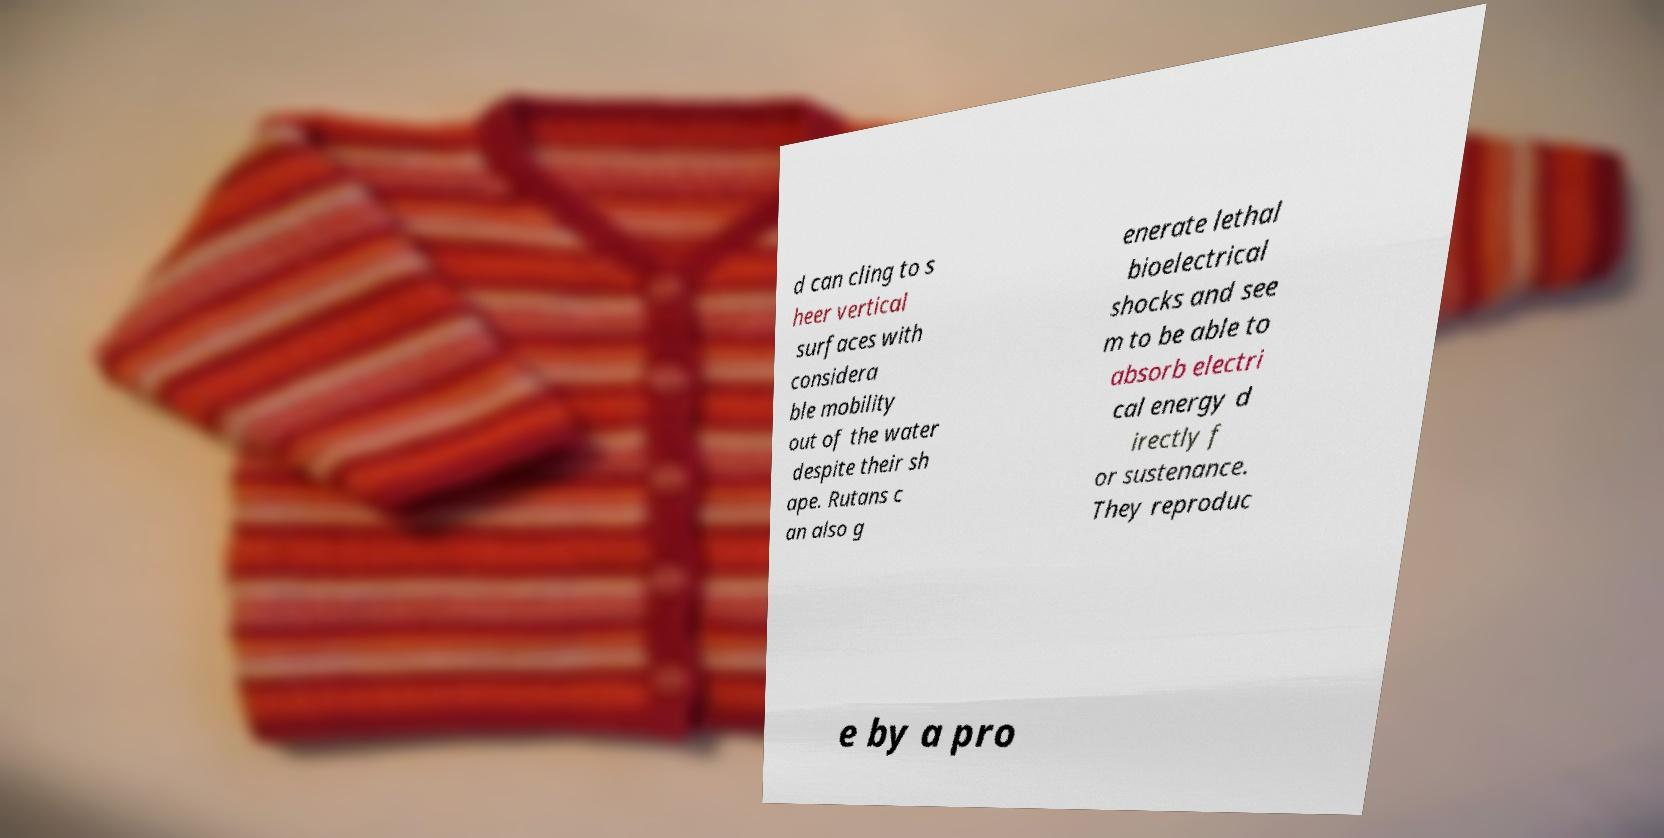Can you accurately transcribe the text from the provided image for me? d can cling to s heer vertical surfaces with considera ble mobility out of the water despite their sh ape. Rutans c an also g enerate lethal bioelectrical shocks and see m to be able to absorb electri cal energy d irectly f or sustenance. They reproduc e by a pro 